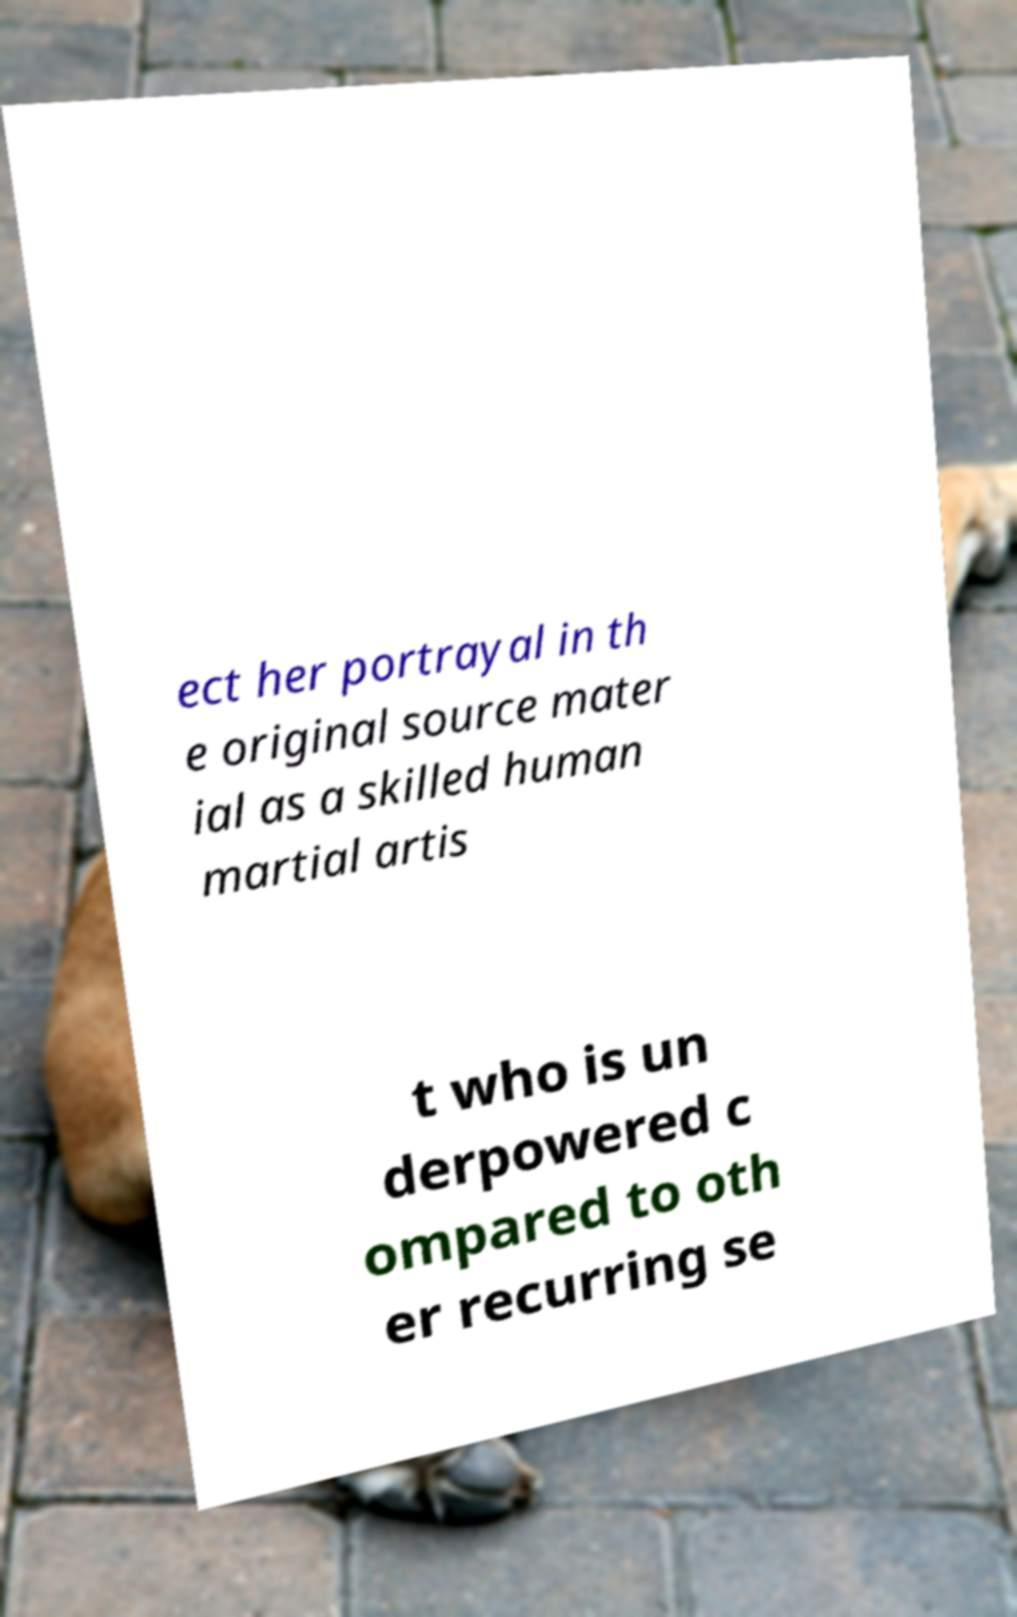I need the written content from this picture converted into text. Can you do that? ect her portrayal in th e original source mater ial as a skilled human martial artis t who is un derpowered c ompared to oth er recurring se 